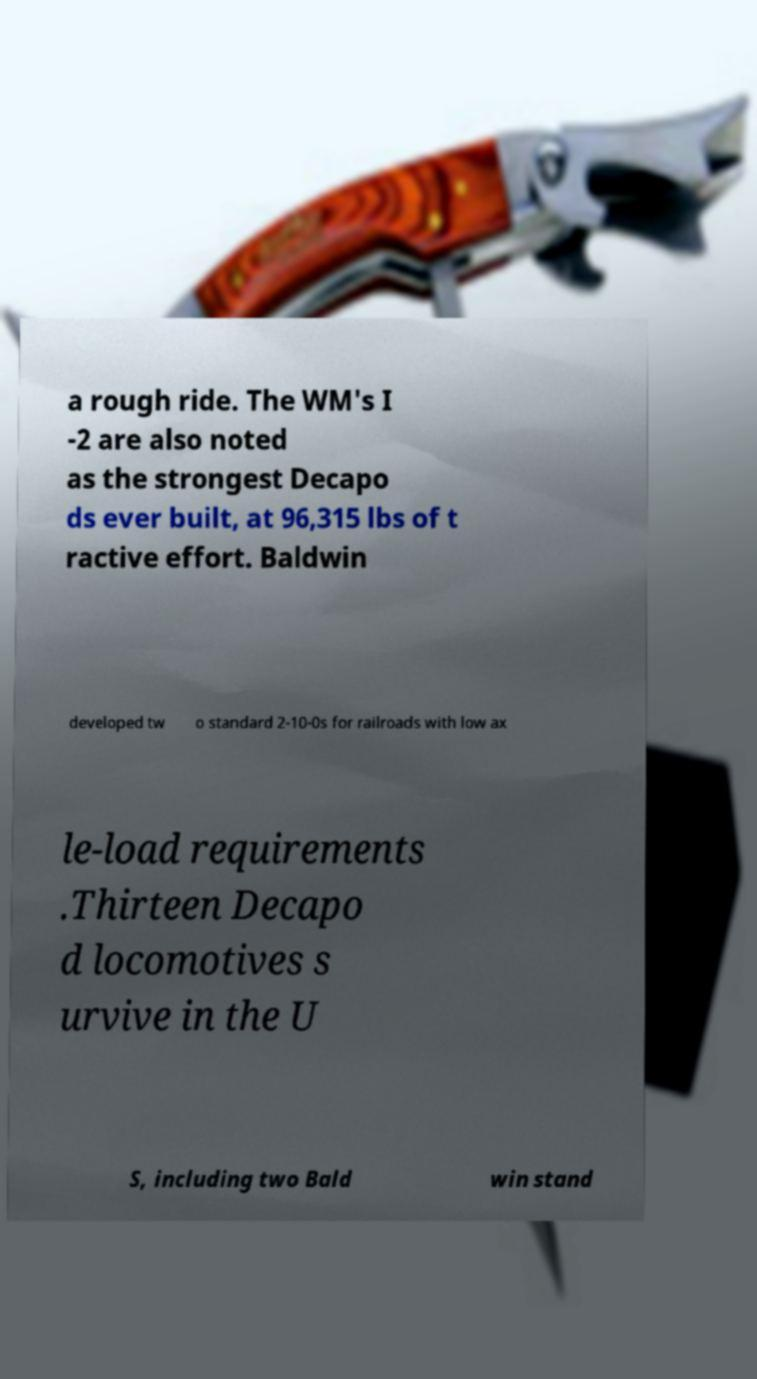Please identify and transcribe the text found in this image. a rough ride. The WM's I -2 are also noted as the strongest Decapo ds ever built, at 96,315 lbs of t ractive effort. Baldwin developed tw o standard 2-10-0s for railroads with low ax le-load requirements .Thirteen Decapo d locomotives s urvive in the U S, including two Bald win stand 